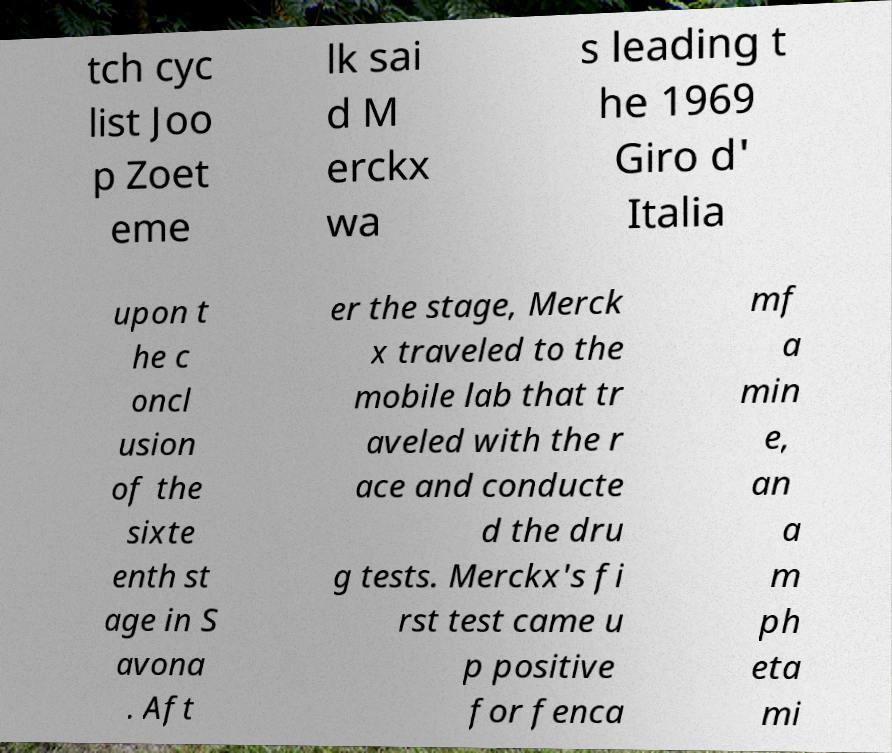Can you accurately transcribe the text from the provided image for me? tch cyc list Joo p Zoet eme lk sai d M erckx wa s leading t he 1969 Giro d' Italia upon t he c oncl usion of the sixte enth st age in S avona . Aft er the stage, Merck x traveled to the mobile lab that tr aveled with the r ace and conducte d the dru g tests. Merckx's fi rst test came u p positive for fenca mf a min e, an a m ph eta mi 